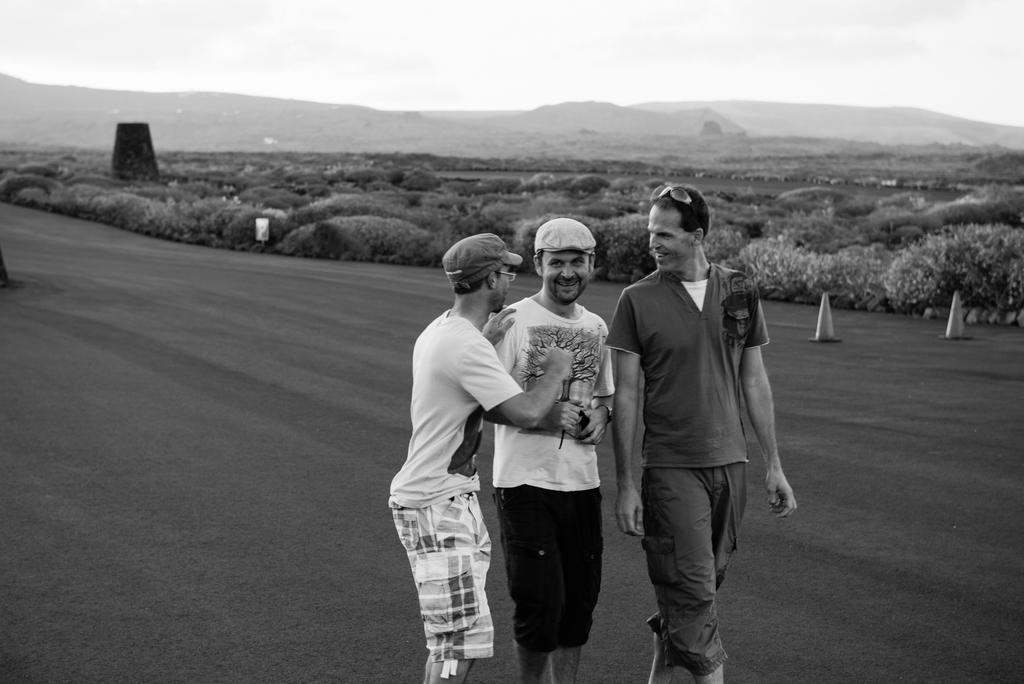How many people are in the image? There are three persons in the image. What are the persons doing in the image? The persons are walking and smiling. What can be seen in the background of the image? There are trees and hills in the background of the image. What is visible at the top of the image? The sky is visible at the top of the image. What type of feast is being prepared by the visitors in the image? There are no visitors or feast preparation present in the image; it features three persons walking and smiling. What territory do the persons in the image belong to? The image does not provide information about the persons' territory or origin. 